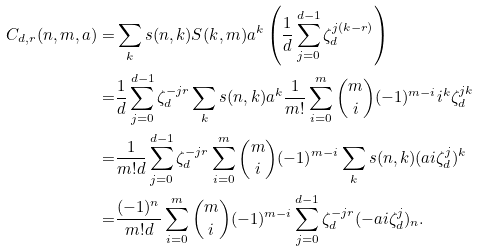<formula> <loc_0><loc_0><loc_500><loc_500>C _ { d , r } ( n , m , a ) = & \sum _ { k } s ( n , k ) S ( k , m ) a ^ { k } \left ( \frac { 1 } { d } \sum _ { j = 0 } ^ { d - 1 } \zeta _ { d } ^ { j ( k - r ) } \right ) \\ = & \frac { 1 } { d } \sum _ { j = 0 } ^ { d - 1 } \zeta _ { d } ^ { - j r } \sum _ { k } s ( n , k ) a ^ { k } \frac { 1 } { m ! } \sum _ { i = 0 } ^ { m } \binom { m } { i } ( - 1 ) ^ { m - i } i ^ { k } \zeta _ { d } ^ { j k } \\ = & \frac { 1 } { m ! d } \sum _ { j = 0 } ^ { d - 1 } \zeta _ { d } ^ { - j r } \sum _ { i = 0 } ^ { m } \binom { m } { i } ( - 1 ) ^ { m - i } \sum _ { k } s ( n , k ) ( a i \zeta _ { d } ^ { j } ) ^ { k } \\ = & \frac { ( - 1 ) ^ { n } } { m ! d } \sum _ { i = 0 } ^ { m } \binom { m } { i } ( - 1 ) ^ { m - i } \sum _ { j = 0 } ^ { d - 1 } \zeta _ { d } ^ { - j r } ( - a i \zeta _ { d } ^ { j } ) _ { n } .</formula> 